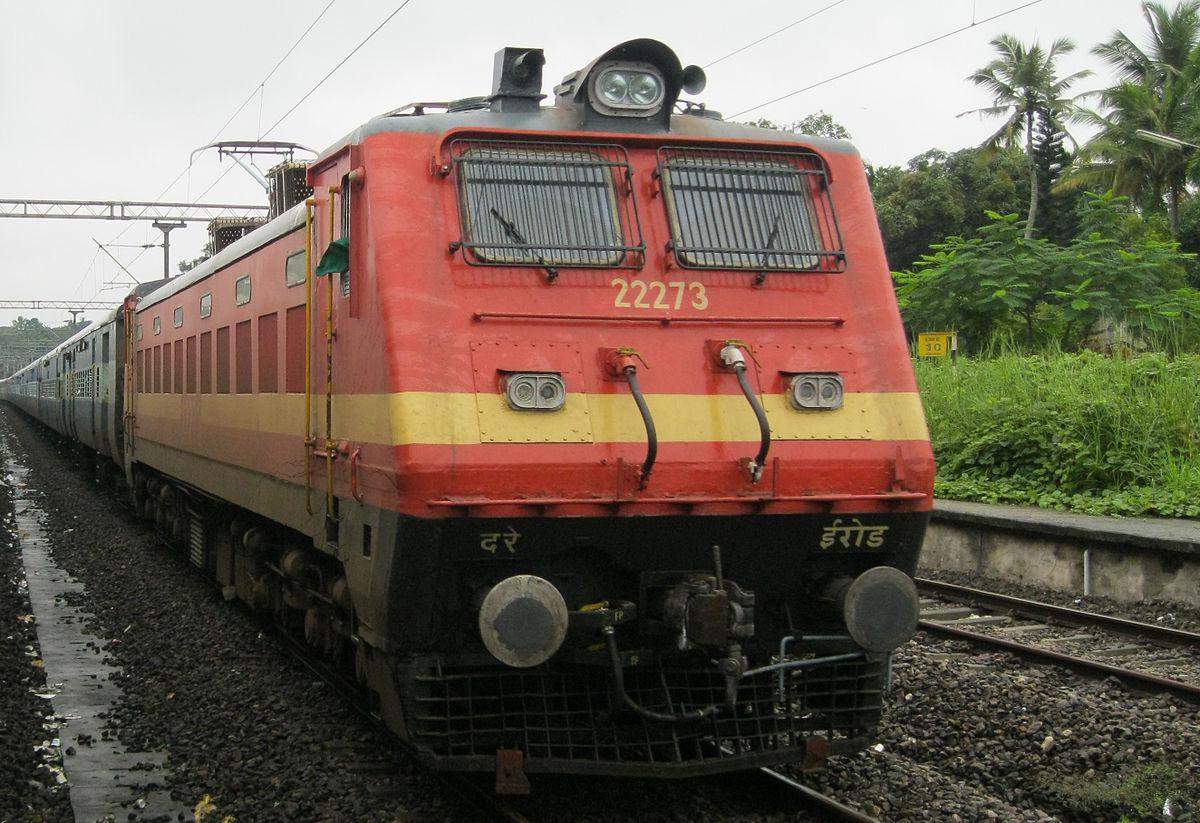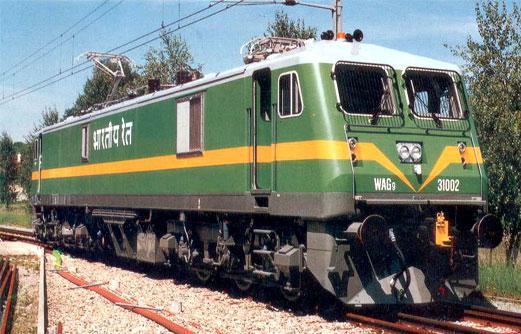The first image is the image on the left, the second image is the image on the right. Given the left and right images, does the statement "At least one train in the image on the left has a full length white stripe." hold true? Answer yes or no. Yes. The first image is the image on the left, the second image is the image on the right. Examine the images to the left and right. Is the description "The left image includes a train that is reddish-orange with a yellow horizontal stripe." accurate? Answer yes or no. Yes. 